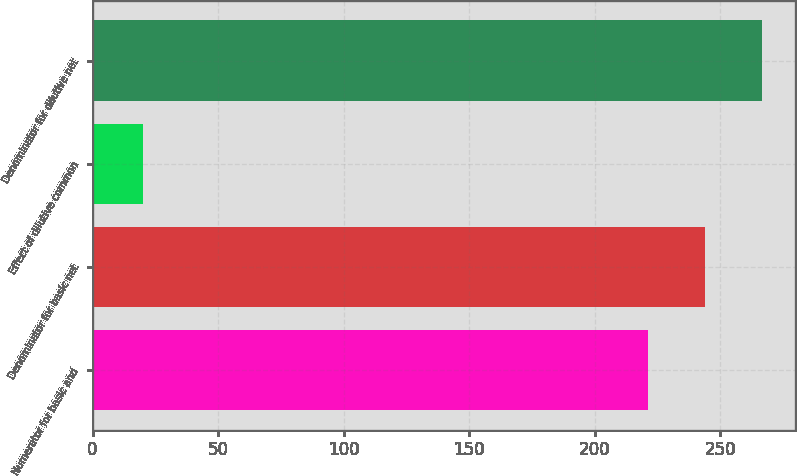<chart> <loc_0><loc_0><loc_500><loc_500><bar_chart><fcel>Numerator for basic and<fcel>Denominator for basic net<fcel>Effect of dilutive common<fcel>Denominator for dilutive net<nl><fcel>221.1<fcel>243.8<fcel>20<fcel>266.5<nl></chart> 